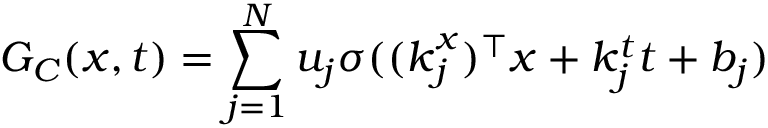<formula> <loc_0><loc_0><loc_500><loc_500>G _ { C } ( x , t ) = \sum _ { j = 1 } ^ { N } u _ { j } \sigma ( ( k _ { j } ^ { x } ) ^ { \top } x + k _ { j } ^ { t } t + b _ { j } )</formula> 